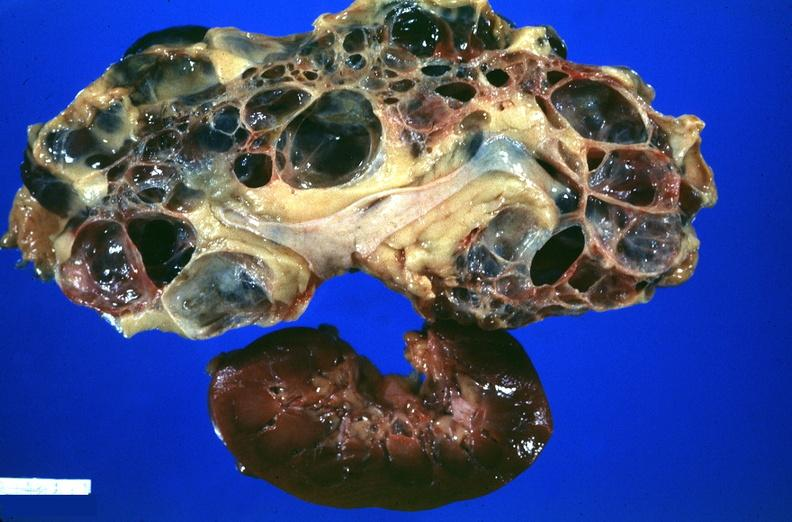does this image show kidney, adult polycystic kidney?
Answer the question using a single word or phrase. Yes 